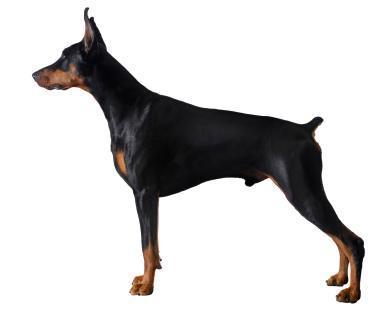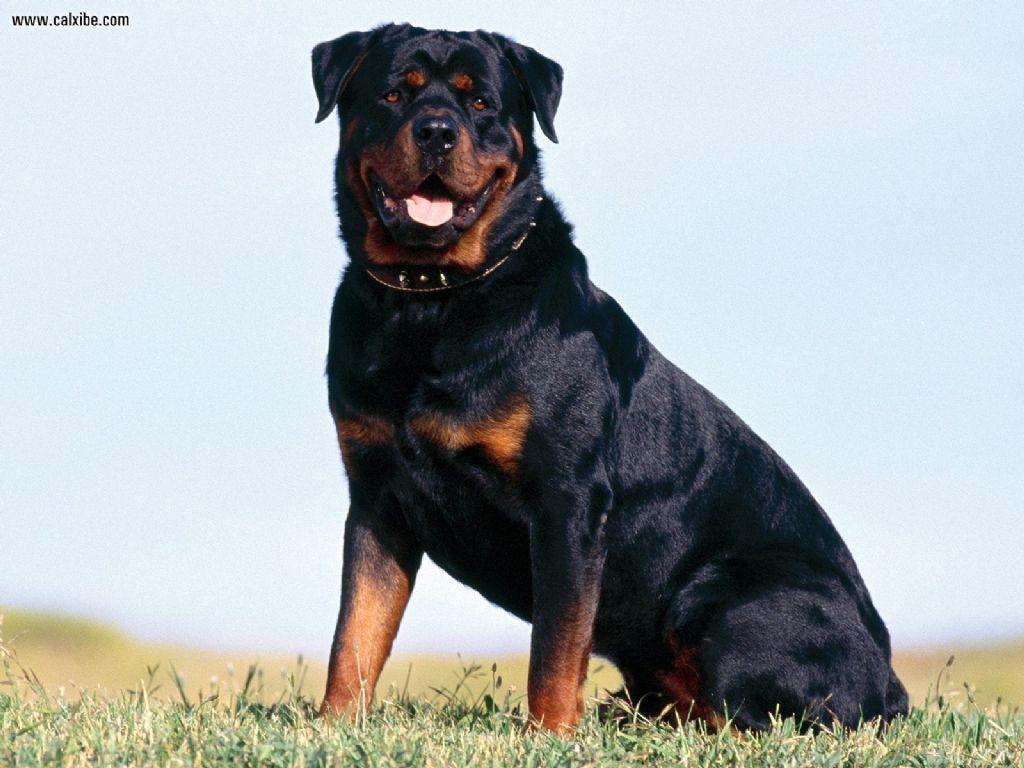The first image is the image on the left, the second image is the image on the right. Given the left and right images, does the statement "There are a total of 4 dogs sitting in pairs." hold true? Answer yes or no. No. The first image is the image on the left, the second image is the image on the right. Considering the images on both sides, is "There is one dog without a collar" valid? Answer yes or no. Yes. 